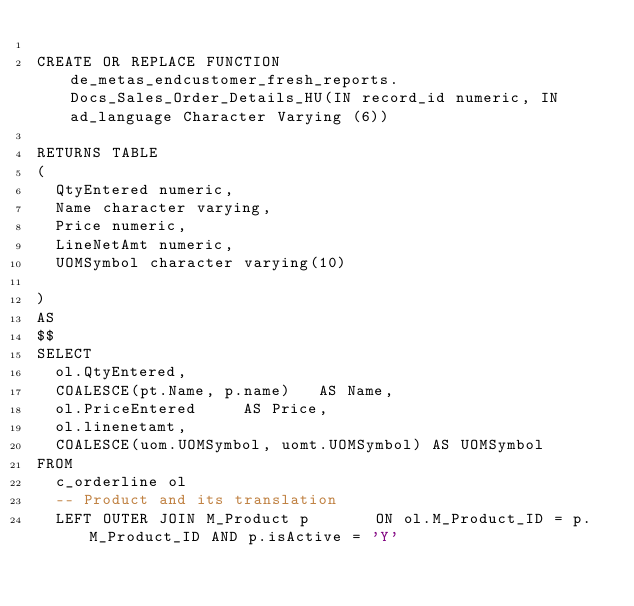<code> <loc_0><loc_0><loc_500><loc_500><_SQL_>
CREATE OR REPLACE FUNCTION de_metas_endcustomer_fresh_reports.Docs_Sales_Order_Details_HU(IN record_id numeric, IN ad_language Character Varying (6))

RETURNS TABLE
(
	QtyEntered numeric, 
	Name character varying,
	Price numeric, 
	LineNetAmt numeric,  
	UOMSymbol character varying(10)

)
AS
$$
SELECT
	ol.QtyEntered,
	COALESCE(pt.Name, p.name)		AS Name,
	ol.PriceEntered			AS Price,
	ol.linenetamt,
	COALESCE(uom.UOMSymbol, uomt.UOMSymbol)	AS UOMSymbol
FROM
	c_orderline ol
	-- Product and its translation
	LEFT OUTER JOIN M_Product p 			ON ol.M_Product_ID = p.M_Product_ID AND p.isActive = 'Y'</code> 